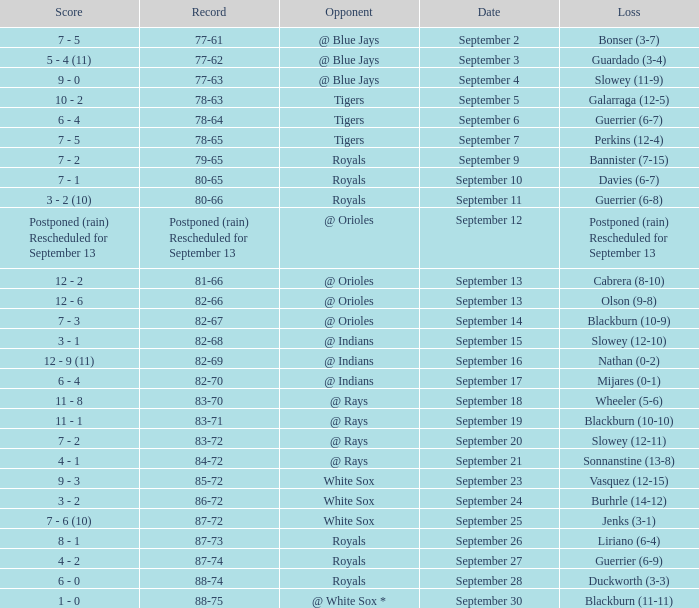What opponent has the record of 78-63? Tigers. 